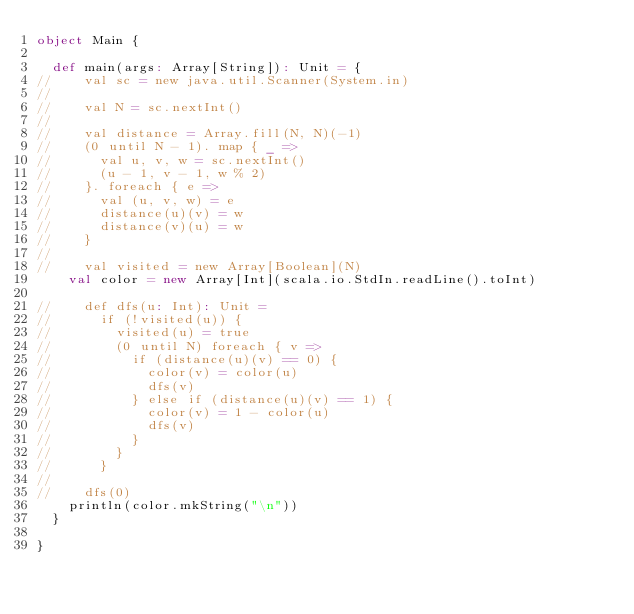Convert code to text. <code><loc_0><loc_0><loc_500><loc_500><_Scala_>object Main {

  def main(args: Array[String]): Unit = {
//    val sc = new java.util.Scanner(System.in)
//
//    val N = sc.nextInt()
//
//    val distance = Array.fill(N, N)(-1)
//    (0 until N - 1). map { _ =>
//      val u, v, w = sc.nextInt()
//      (u - 1, v - 1, w % 2)
//    }. foreach { e =>
//      val (u, v, w) = e
//      distance(u)(v) = w
//      distance(v)(u) = w
//    }
//
//    val visited = new Array[Boolean](N)
    val color = new Array[Int](scala.io.StdIn.readLine().toInt)

//    def dfs(u: Int): Unit =
//      if (!visited(u)) {
//        visited(u) = true
//        (0 until N) foreach { v =>
//          if (distance(u)(v) == 0) {
//            color(v) = color(u)
//            dfs(v)
//          } else if (distance(u)(v) == 1) {
//            color(v) = 1 - color(u)
//            dfs(v)
//          }
//        }
//      }
//
//    dfs(0)
    println(color.mkString("\n"))
  }

}</code> 